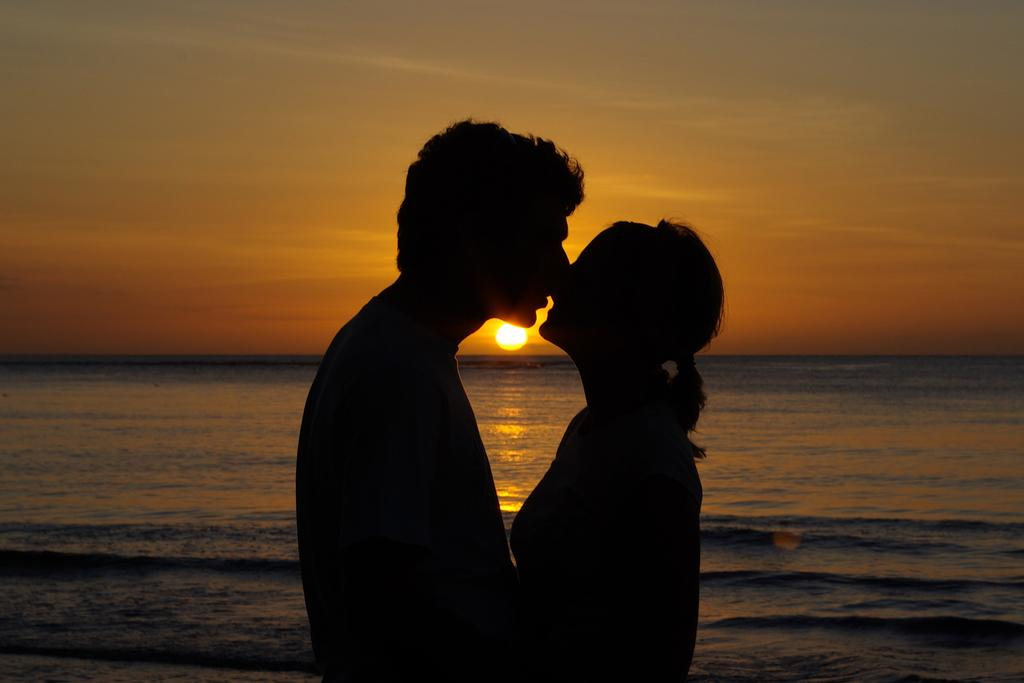How many people are present in the image? There are two people, a man and a woman, present in the image. What is visible in the background of the image? There is water visible in the background of the image. Can the sun be seen in the image? Yes, the sun is observable in the sky. What else can be seen in the sky? There are clouds in the sky. What type of snail can be seen crawling on the man's shoulder in the image? There is no snail present on the man's shoulder or anywhere else in the image. 